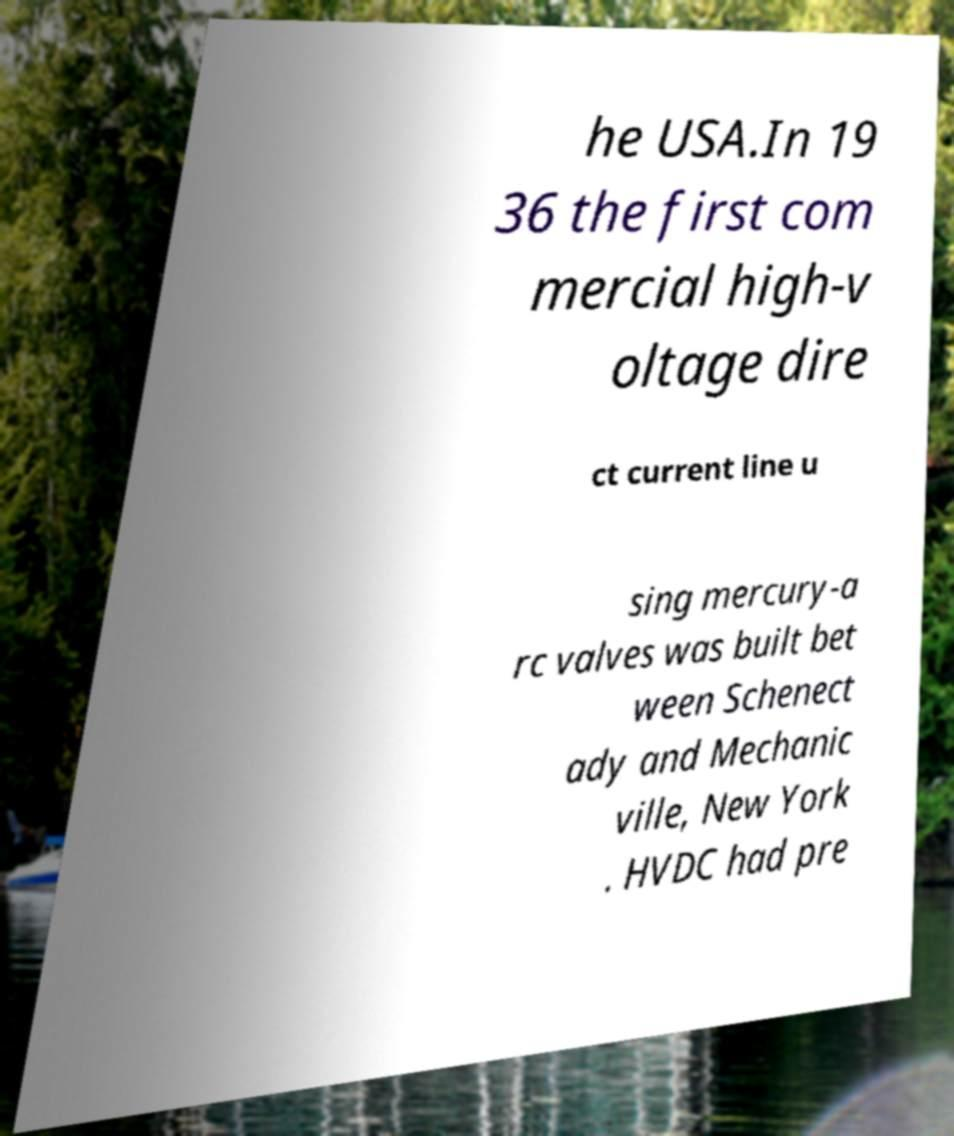Could you assist in decoding the text presented in this image and type it out clearly? he USA.In 19 36 the first com mercial high-v oltage dire ct current line u sing mercury-a rc valves was built bet ween Schenect ady and Mechanic ville, New York . HVDC had pre 